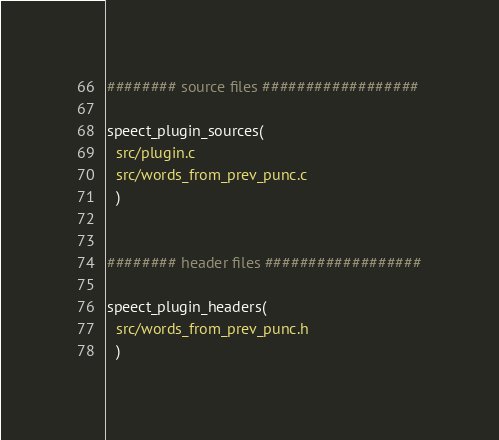Convert code to text. <code><loc_0><loc_0><loc_500><loc_500><_CMake_>######## source files ##################

speect_plugin_sources(
  src/plugin.c
  src/words_from_prev_punc.c
  )


######## header files ##################

speect_plugin_headers(
  src/words_from_prev_punc.h
  )

</code> 